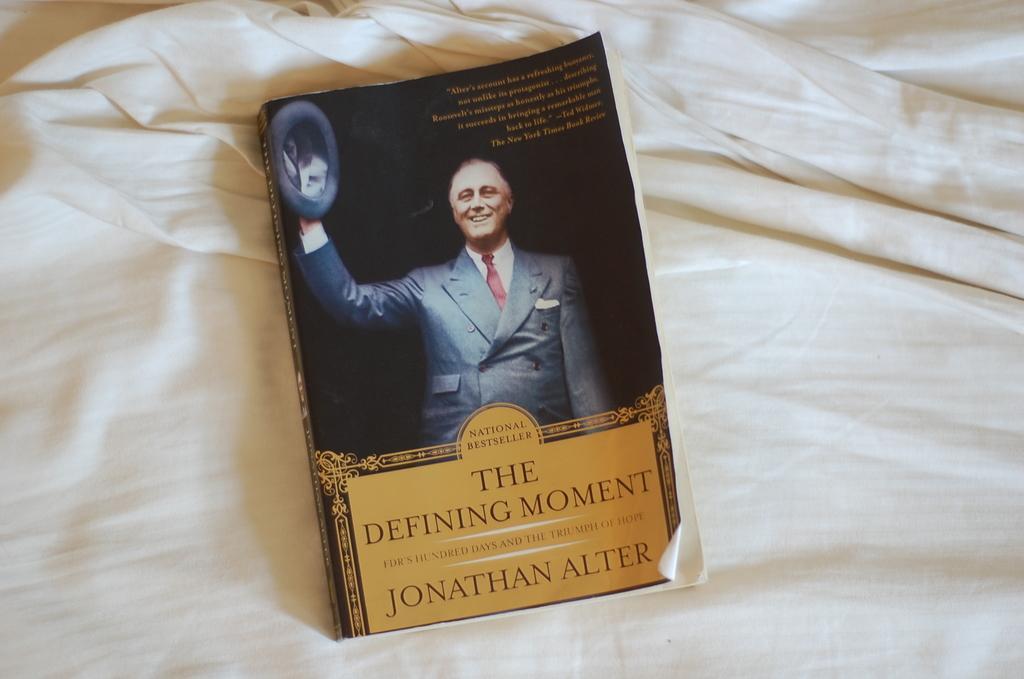Can you describe this image briefly? In this image we can see a book on the cloth, book has some text, and images on its cover page. 